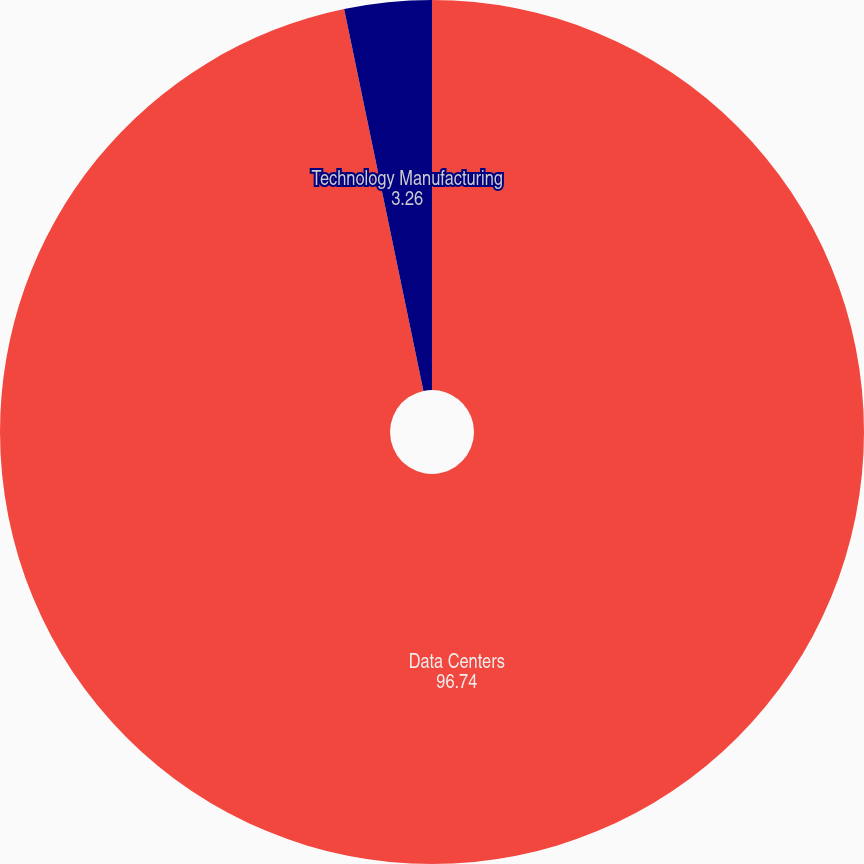<chart> <loc_0><loc_0><loc_500><loc_500><pie_chart><fcel>Data Centers<fcel>Technology Manufacturing<nl><fcel>96.74%<fcel>3.26%<nl></chart> 